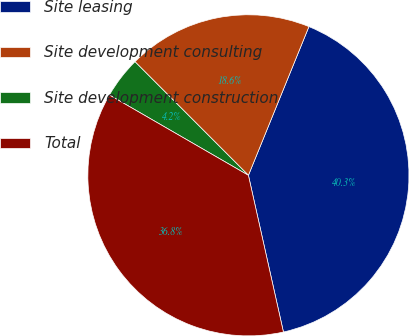<chart> <loc_0><loc_0><loc_500><loc_500><pie_chart><fcel>Site leasing<fcel>Site development consulting<fcel>Site development construction<fcel>Total<nl><fcel>40.35%<fcel>18.64%<fcel>4.17%<fcel>36.84%<nl></chart> 